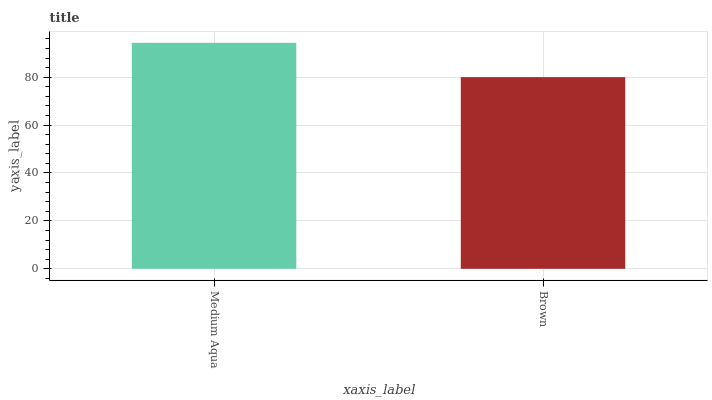Is Brown the minimum?
Answer yes or no. Yes. Is Medium Aqua the maximum?
Answer yes or no. Yes. Is Brown the maximum?
Answer yes or no. No. Is Medium Aqua greater than Brown?
Answer yes or no. Yes. Is Brown less than Medium Aqua?
Answer yes or no. Yes. Is Brown greater than Medium Aqua?
Answer yes or no. No. Is Medium Aqua less than Brown?
Answer yes or no. No. Is Medium Aqua the high median?
Answer yes or no. Yes. Is Brown the low median?
Answer yes or no. Yes. Is Brown the high median?
Answer yes or no. No. Is Medium Aqua the low median?
Answer yes or no. No. 